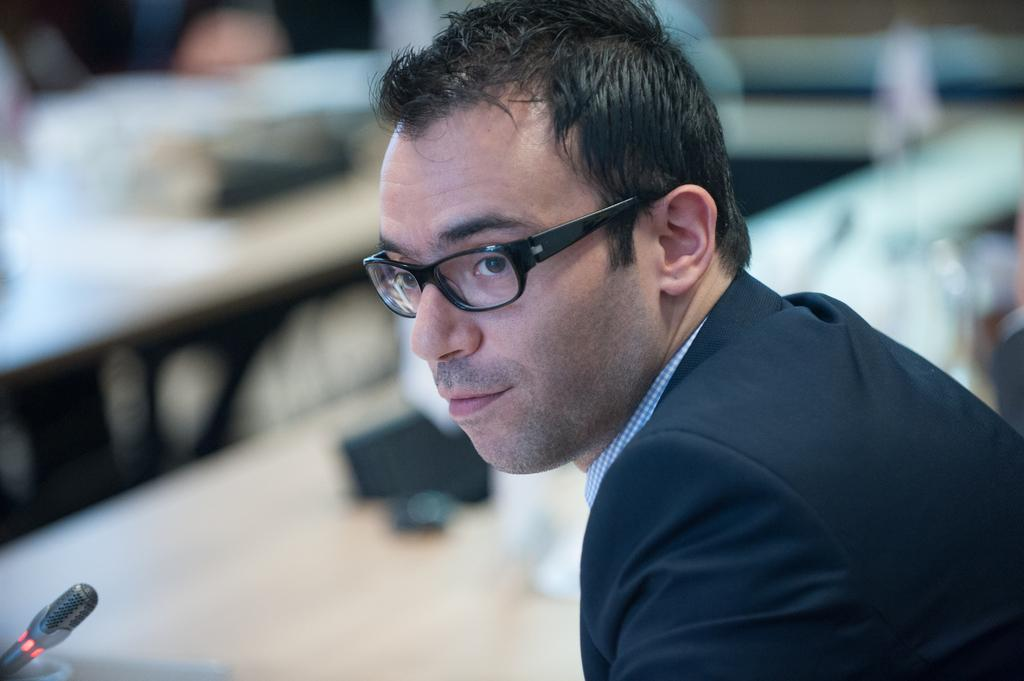Who is present in the image? There is a person in the image. What is the person wearing? The person is wearing a black dress and black-colored spectacles. What object is in front of the person? There is a microphone in front of the person. Can you describe the background of the image? The background of the image is blurry. Can you tell me how many times the person kicks the pail in the image? There is no pail present in the image, so the person cannot kick it. 